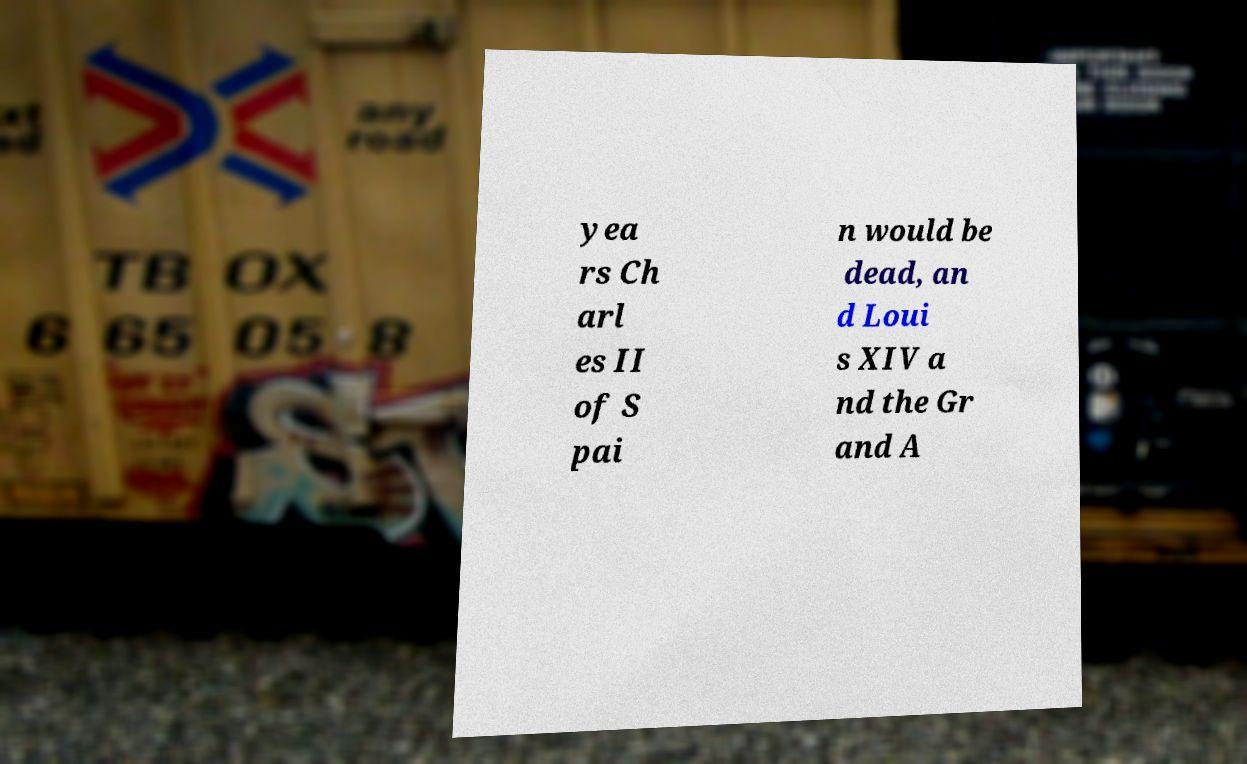I need the written content from this picture converted into text. Can you do that? yea rs Ch arl es II of S pai n would be dead, an d Loui s XIV a nd the Gr and A 